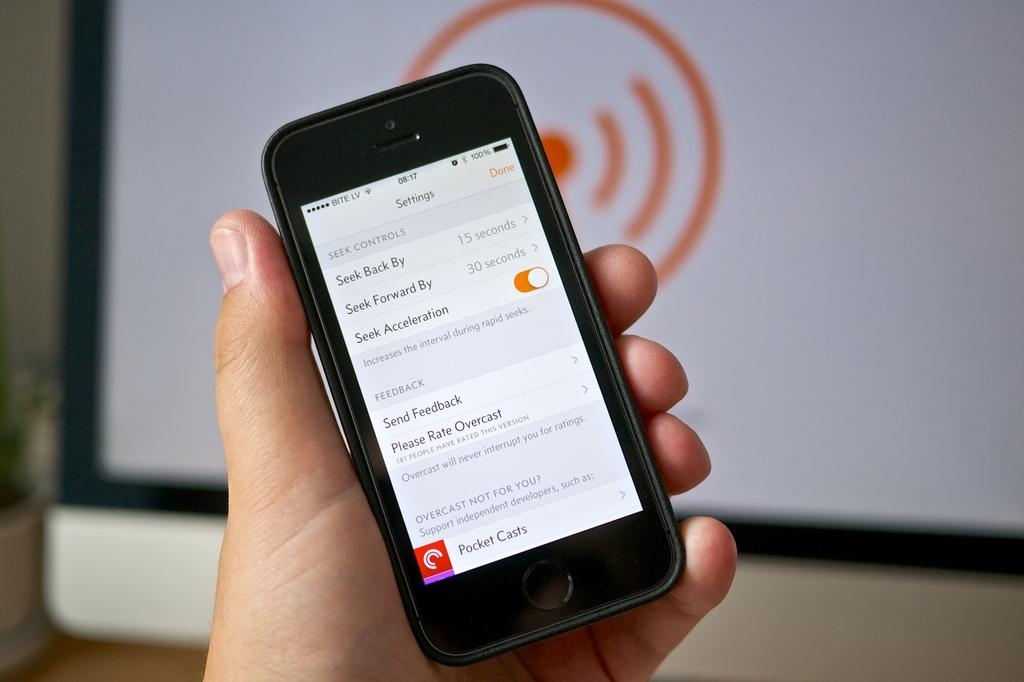<image>
Summarize the visual content of the image. A black phone with a settings screen pulled up on its display. 